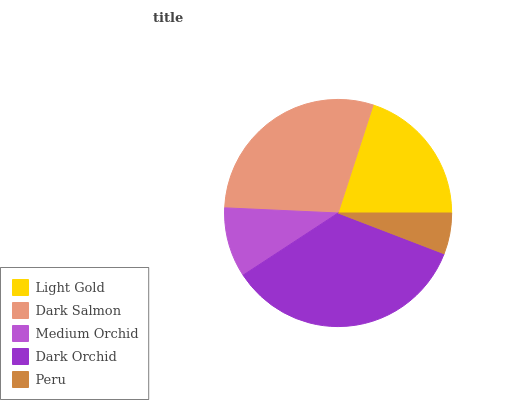Is Peru the minimum?
Answer yes or no. Yes. Is Dark Orchid the maximum?
Answer yes or no. Yes. Is Dark Salmon the minimum?
Answer yes or no. No. Is Dark Salmon the maximum?
Answer yes or no. No. Is Dark Salmon greater than Light Gold?
Answer yes or no. Yes. Is Light Gold less than Dark Salmon?
Answer yes or no. Yes. Is Light Gold greater than Dark Salmon?
Answer yes or no. No. Is Dark Salmon less than Light Gold?
Answer yes or no. No. Is Light Gold the high median?
Answer yes or no. Yes. Is Light Gold the low median?
Answer yes or no. Yes. Is Dark Orchid the high median?
Answer yes or no. No. Is Dark Orchid the low median?
Answer yes or no. No. 